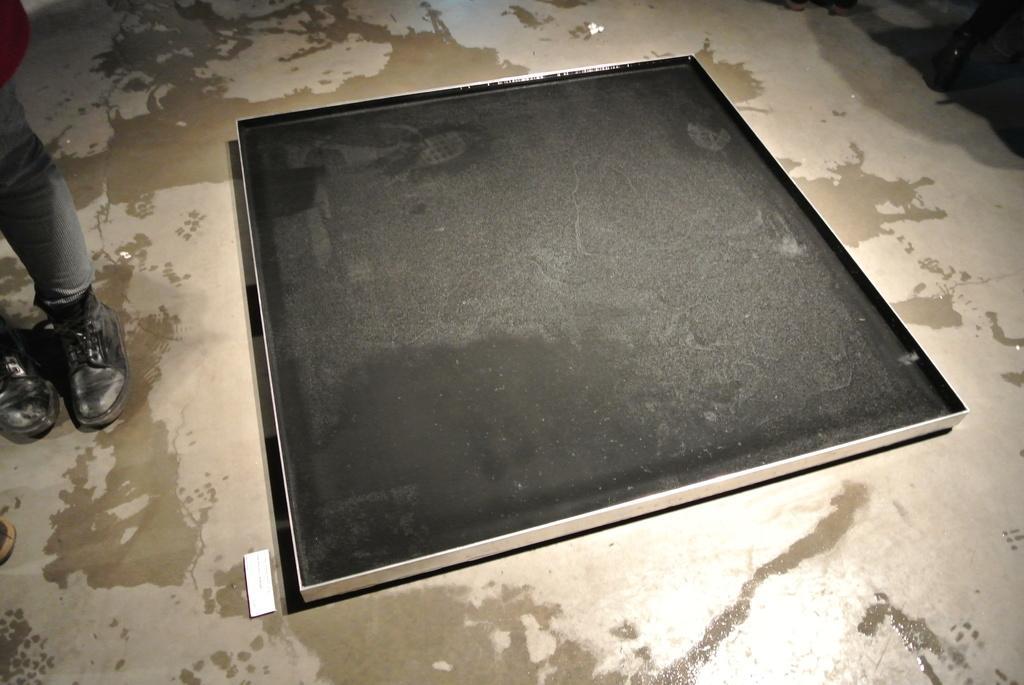In one or two sentences, can you explain what this image depicts? In the image on the floor there is a big tray which is in black color. On the left side of the image there are legs of a person with shoes. 